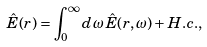<formula> <loc_0><loc_0><loc_500><loc_500>\hat { E } ( { r } ) = \int _ { 0 } ^ { \infty } d \omega \, \hat { E } ( { r } , \omega ) + H . c . ,</formula> 